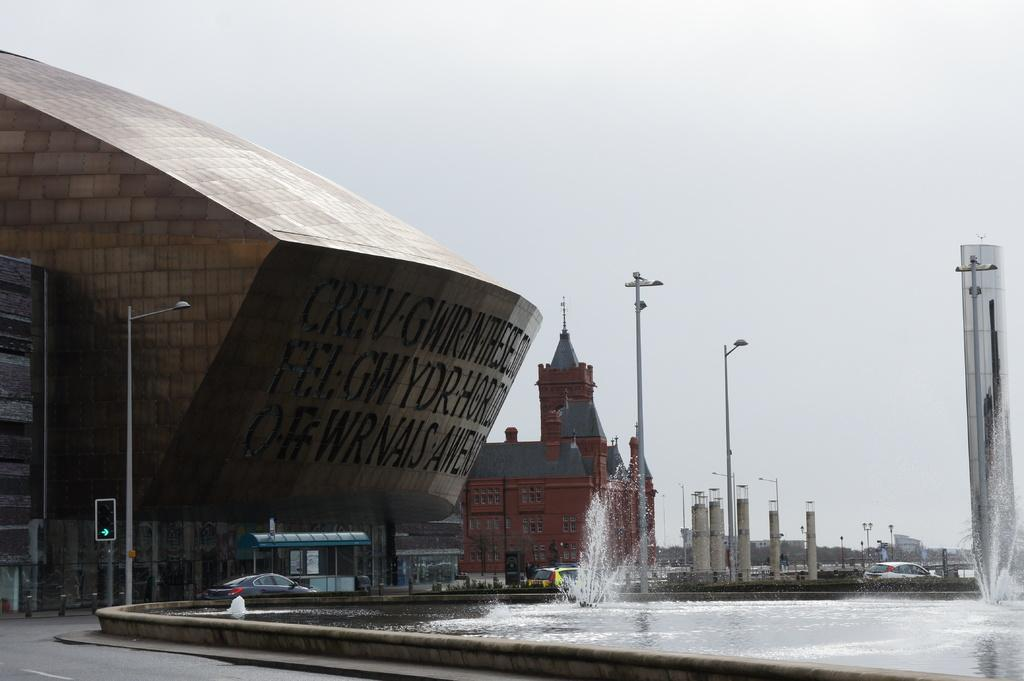What type of structures can be seen in the image? There are buildings in the image. What objects are present alongside the buildings? There are poles, lights, and traffic lights on the left side of the image. Are there any vehicles in the image? Yes, there are vehicles in the image. What natural element is visible in the image? There is water visible in the image. How many stamps are on the traffic lights in the image? There are no stamps present on the traffic lights in the image. What type of stone can be seen in the image? There is no stone visible in the image. 